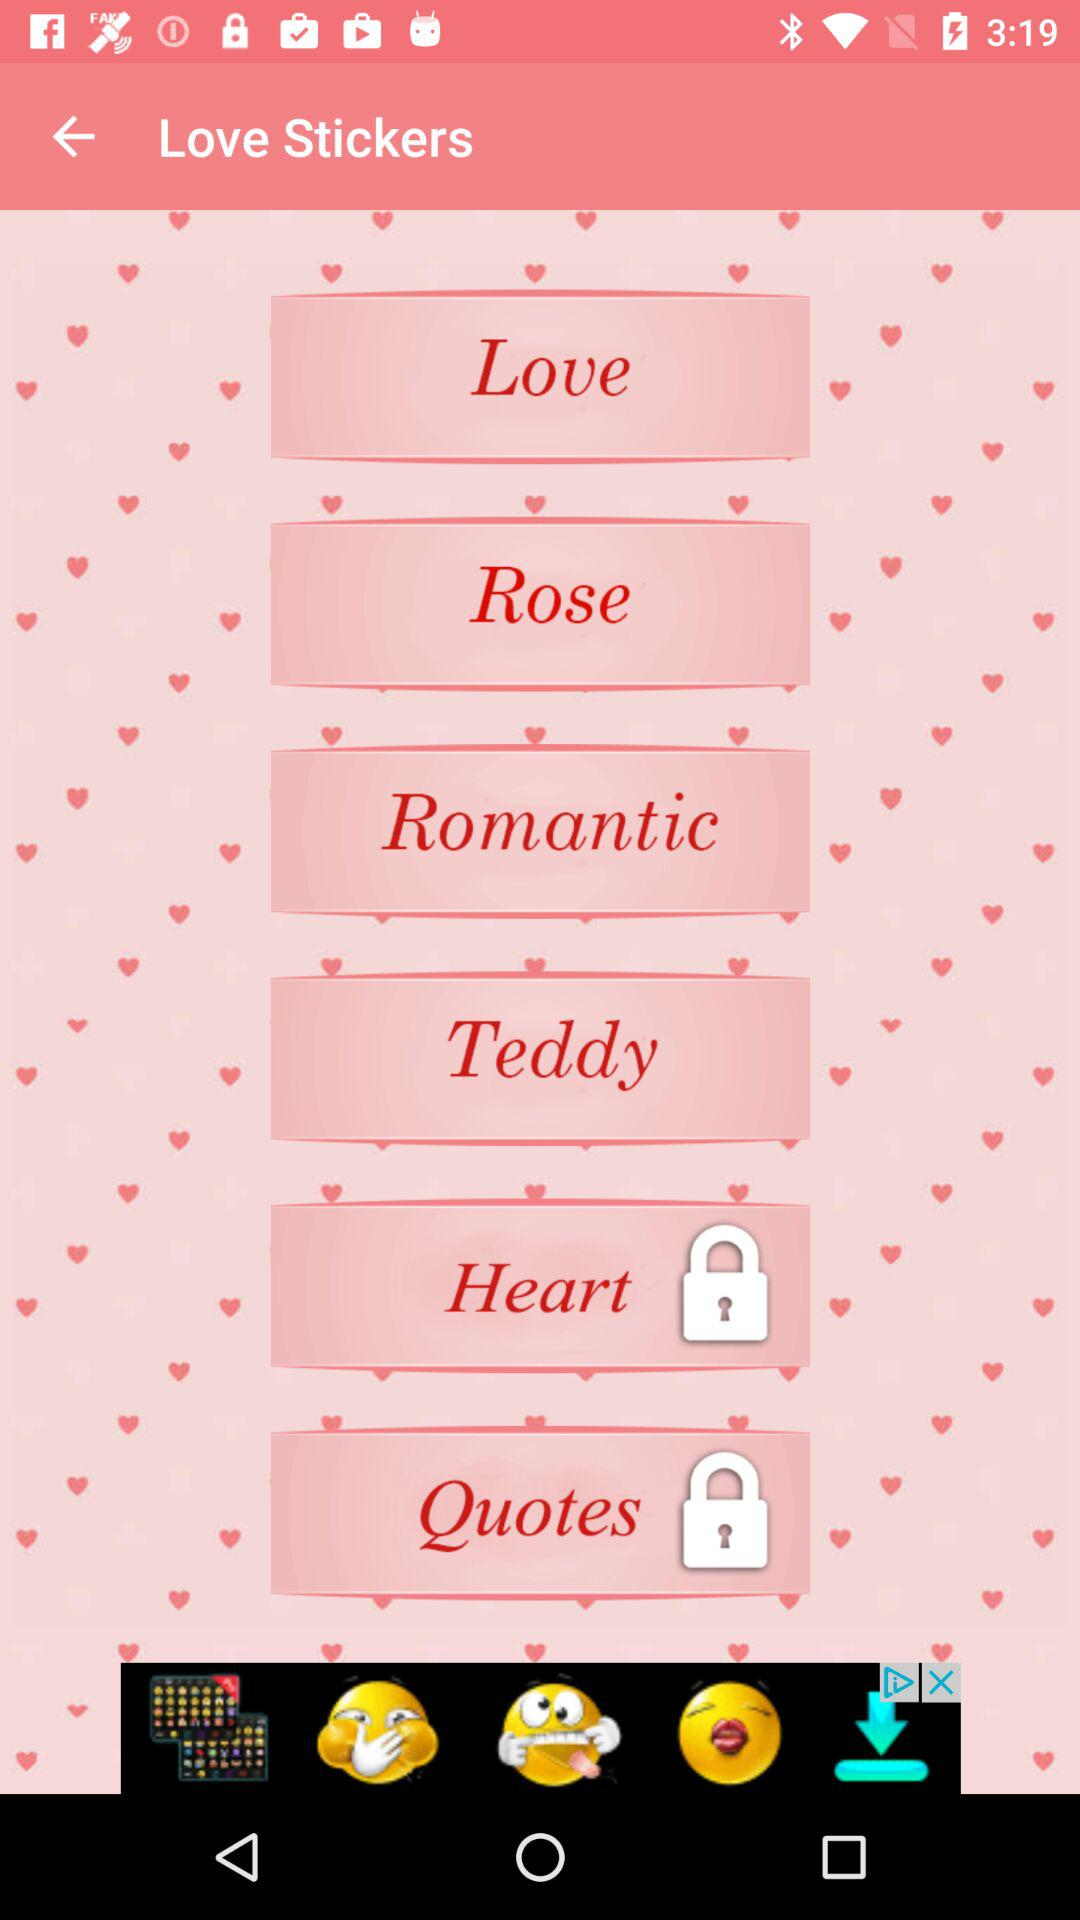Which love stickers are locked? The locked love stickers are "Heart" and "Quotes". 